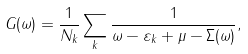<formula> <loc_0><loc_0><loc_500><loc_500>G ( \omega ) = \frac { 1 } { N _ { k } } \sum _ { k } \frac { 1 } { \omega - \varepsilon _ { k } + \mu - \Sigma ( \omega ) } ,</formula> 